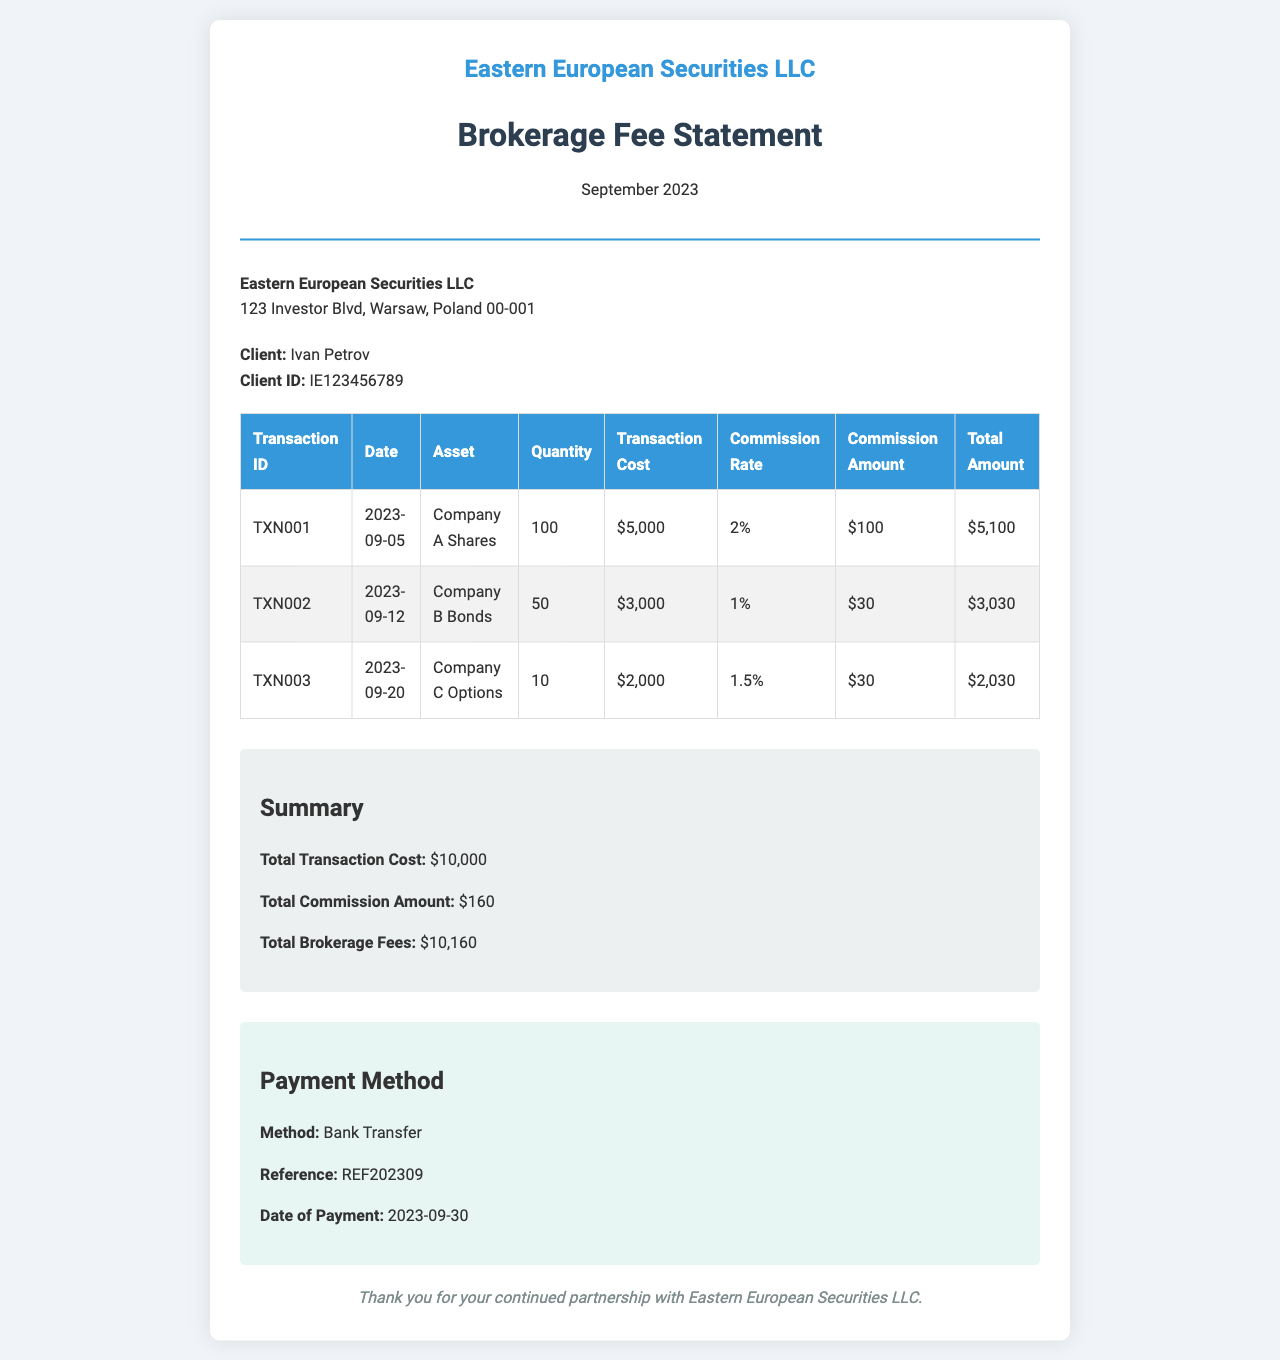What is the total transaction cost? The total transaction cost is summarized at the end of the document, which is the sum of all individual transaction costs.
Answer: $10,000 What is the client ID? The client ID is provided in the client details section of the document.
Answer: IE123456789 What date was the payment made? The payment method section specifies the date of payment.
Answer: 2023-09-30 What is the commission amount for Company A Shares? The commission amount for Company A Shares is listed in the transaction table.
Answer: $100 How many Company B Bonds were transacted? The quantity of Company B Bonds is shown in the transaction table.
Answer: 50 What is the commission rate for Company C Options? The document provides the commission rate for Company C Options in the transaction table.
Answer: 1.5% What is the total brokerage fees? The total brokerage fees are calculated by adding the total transaction cost and total commission amount.
Answer: $10,160 What is the method of payment? The payment method section details how the payment was made.
Answer: Bank Transfer On what date was the transaction for Company B Bonds executed? The date for the transaction involving Company B Bonds is listed in the transaction table.
Answer: 2023-09-12 